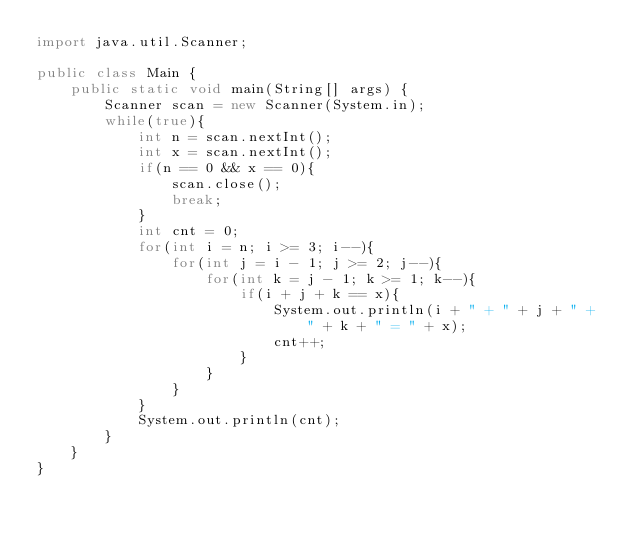<code> <loc_0><loc_0><loc_500><loc_500><_Java_>import java.util.Scanner;

public class Main {
	public static void main(String[] args) {
		Scanner scan = new Scanner(System.in);
		while(true){
			int n = scan.nextInt();
			int x = scan.nextInt();
			if(n == 0 && x == 0){
				scan.close();
				break;
			}
			int cnt = 0;
			for(int i = n; i >= 3; i--){
				for(int j = i - 1; j >= 2; j--){
					for(int k = j - 1; k >= 1; k--){
						if(i + j + k == x){
							System.out.println(i + " + " + j + " + " + k + " = " + x);
							cnt++;
						}
					}
				}
			}
			System.out.println(cnt);
		}
	}
}</code> 